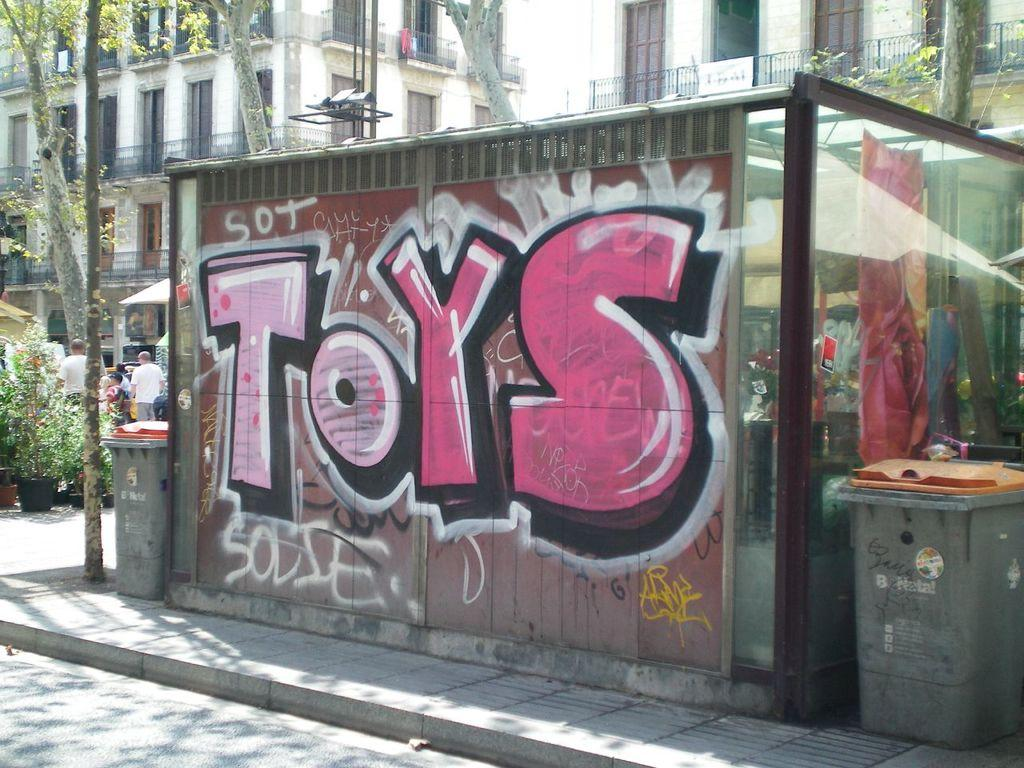<image>
Render a clear and concise summary of the photo. The word Toys has been written in graffiti on a wall. 